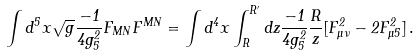Convert formula to latex. <formula><loc_0><loc_0><loc_500><loc_500>\int d ^ { 5 } x \sqrt { g } \frac { - 1 } { 4 g _ { 5 } ^ { 2 } } F _ { M N } F ^ { M N } = \int d ^ { 4 } x \int _ { R } ^ { R ^ { \prime } } d z \frac { - 1 } { 4 g _ { 5 } ^ { 2 } } \frac { R } { z } [ F _ { \mu \nu } ^ { 2 } - 2 F _ { \mu 5 } ^ { 2 } ] \, .</formula> 